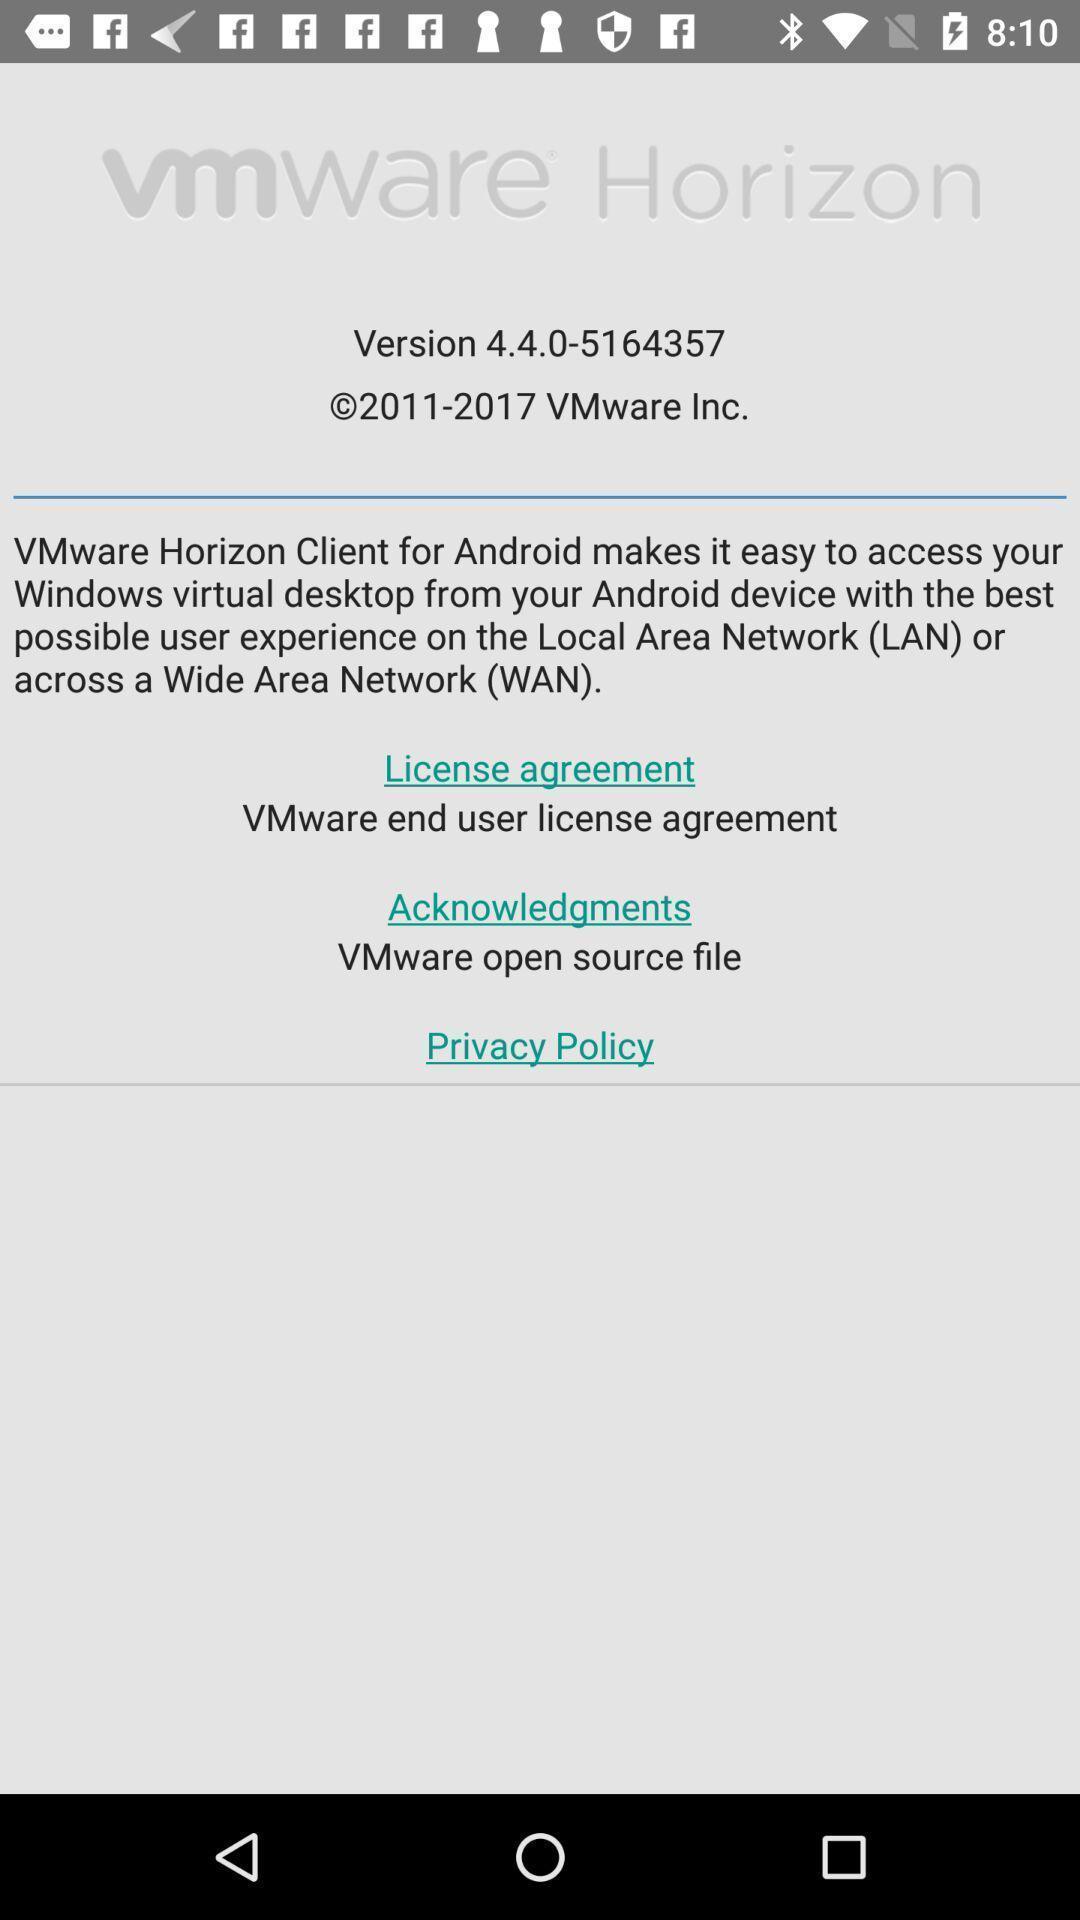Describe the key features of this screenshot. Page of vmware horizon of the app. 